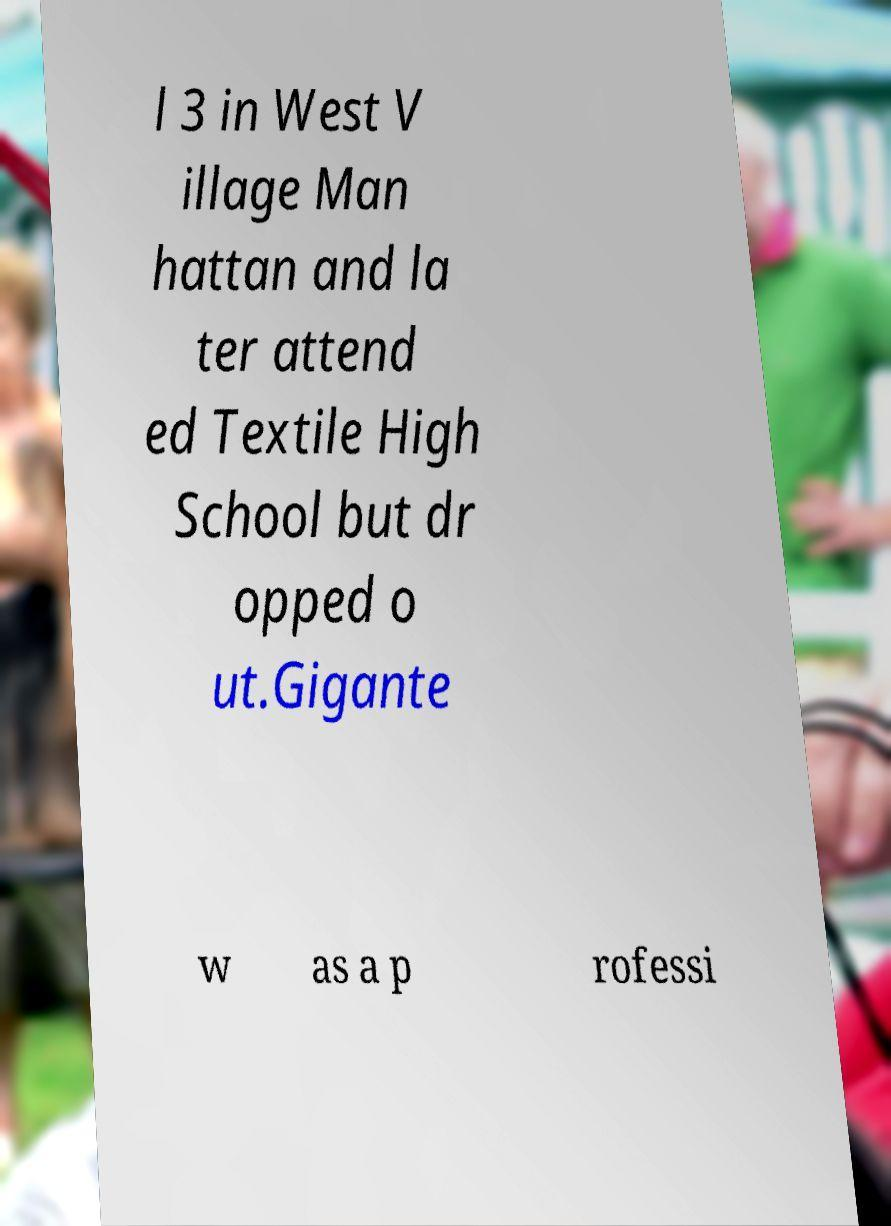Could you extract and type out the text from this image? l 3 in West V illage Man hattan and la ter attend ed Textile High School but dr opped o ut.Gigante w as a p rofessi 